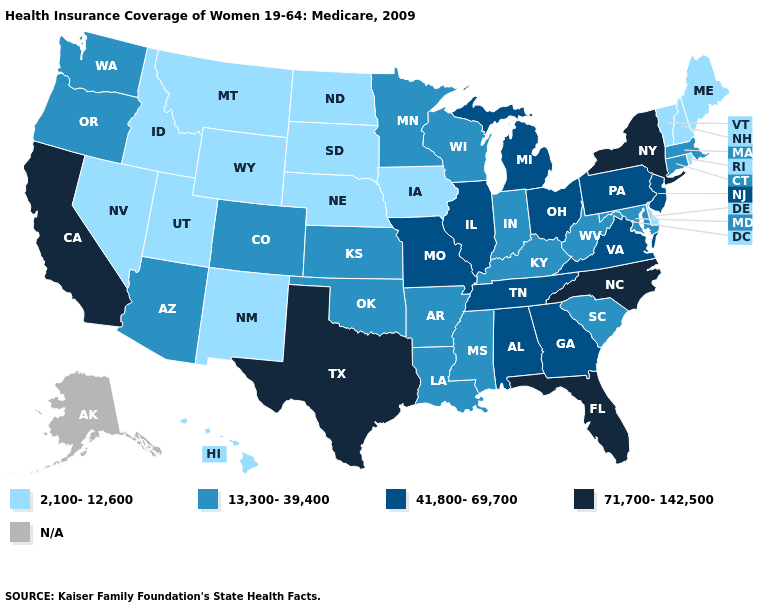Name the states that have a value in the range 2,100-12,600?
Concise answer only. Delaware, Hawaii, Idaho, Iowa, Maine, Montana, Nebraska, Nevada, New Hampshire, New Mexico, North Dakota, Rhode Island, South Dakota, Utah, Vermont, Wyoming. Does Nebraska have the lowest value in the USA?
Be succinct. Yes. What is the lowest value in states that border Arizona?
Concise answer only. 2,100-12,600. What is the value of Iowa?
Short answer required. 2,100-12,600. What is the lowest value in the USA?
Be succinct. 2,100-12,600. Is the legend a continuous bar?
Concise answer only. No. How many symbols are there in the legend?
Keep it brief. 5. Does Nebraska have the highest value in the MidWest?
Concise answer only. No. Does the map have missing data?
Give a very brief answer. Yes. What is the lowest value in the South?
Write a very short answer. 2,100-12,600. What is the value of Idaho?
Short answer required. 2,100-12,600. Which states have the lowest value in the South?
Answer briefly. Delaware. Name the states that have a value in the range N/A?
Quick response, please. Alaska. 